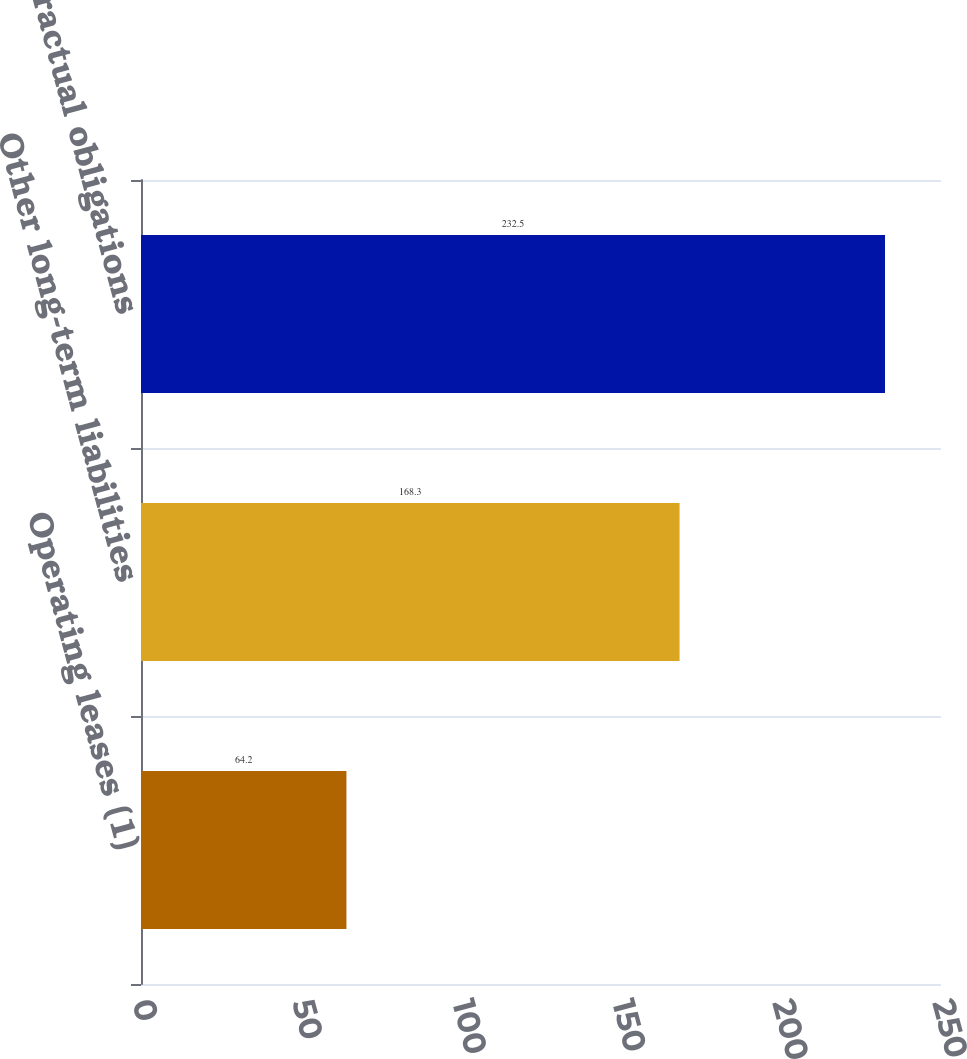Convert chart to OTSL. <chart><loc_0><loc_0><loc_500><loc_500><bar_chart><fcel>Operating leases (1)<fcel>Other long-term liabilities<fcel>Total contractual obligations<nl><fcel>64.2<fcel>168.3<fcel>232.5<nl></chart> 